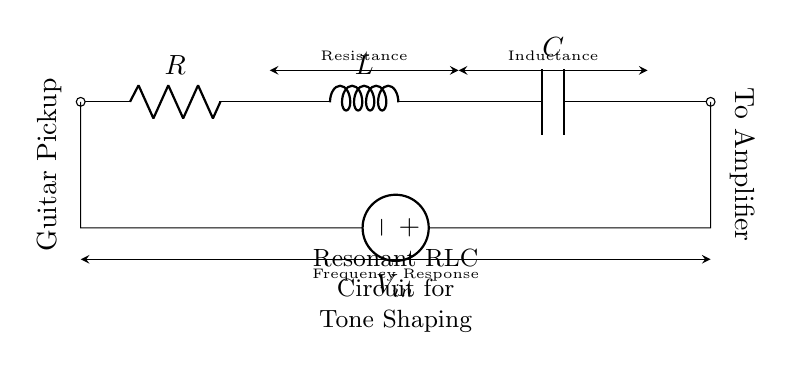What type of components are in this circuit? The circuit contains a resistor, an inductor, and a capacitor, as labeled in the diagram. These three components are integral to the RLC circuit.
Answer: Resistor, Inductor, Capacitor What is the function of the guitar pickup in this circuit? The guitar pickup acts as a source that converts the mechanical vibrations of the guitar strings into an electrical signal, which is then processed by the RLC components for tone shaping.
Answer: Source What is the output of this circuit connected to? The output of the circuit is connected to an amplifier, which boosts the signal for further processing or output to speakers.
Answer: Amplifier How do the components influence frequency response? The resistance, inductance, and capacitance each affect the frequency response of the circuit, determining which frequencies are amplified or attenuated, thus shaping the tone of the guitar.
Answer: Tone shaping What is the overall function of a resonant RLC circuit? A resonant RLC circuit is designed to select specific frequencies from an input signal, enhancing or filtering them according to the values of the resistor, inductor, and capacitor, which are tuned to resonate at a particular frequency.
Answer: Frequency selection 